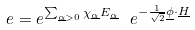Convert formula to latex. <formula><loc_0><loc_0><loc_500><loc_500>e = e ^ { \sum _ { \underline { \alpha } > 0 } \chi _ { \underline { \alpha } } E _ { \underline { \alpha } } } \ e ^ { - \frac { 1 } { \sqrt { 2 } } \underline { \phi } \cdot \underline { H } }</formula> 